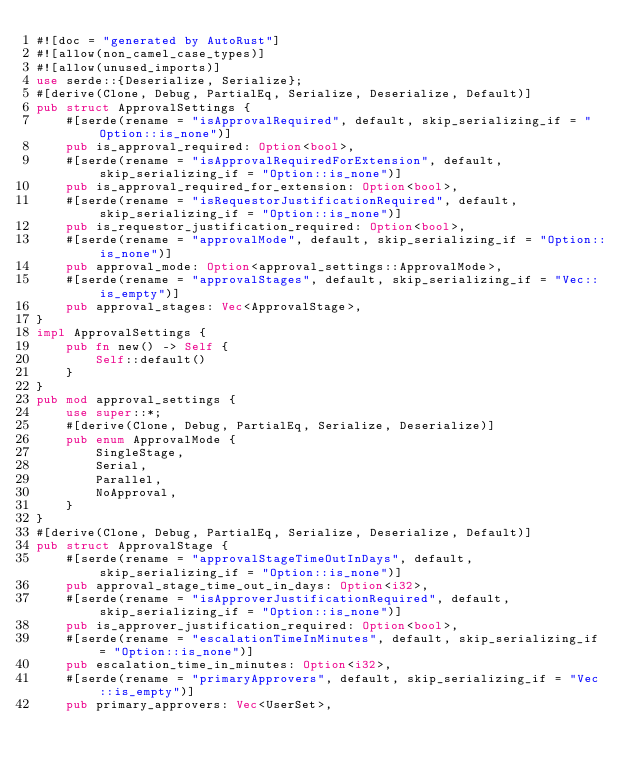<code> <loc_0><loc_0><loc_500><loc_500><_Rust_>#![doc = "generated by AutoRust"]
#![allow(non_camel_case_types)]
#![allow(unused_imports)]
use serde::{Deserialize, Serialize};
#[derive(Clone, Debug, PartialEq, Serialize, Deserialize, Default)]
pub struct ApprovalSettings {
    #[serde(rename = "isApprovalRequired", default, skip_serializing_if = "Option::is_none")]
    pub is_approval_required: Option<bool>,
    #[serde(rename = "isApprovalRequiredForExtension", default, skip_serializing_if = "Option::is_none")]
    pub is_approval_required_for_extension: Option<bool>,
    #[serde(rename = "isRequestorJustificationRequired", default, skip_serializing_if = "Option::is_none")]
    pub is_requestor_justification_required: Option<bool>,
    #[serde(rename = "approvalMode", default, skip_serializing_if = "Option::is_none")]
    pub approval_mode: Option<approval_settings::ApprovalMode>,
    #[serde(rename = "approvalStages", default, skip_serializing_if = "Vec::is_empty")]
    pub approval_stages: Vec<ApprovalStage>,
}
impl ApprovalSettings {
    pub fn new() -> Self {
        Self::default()
    }
}
pub mod approval_settings {
    use super::*;
    #[derive(Clone, Debug, PartialEq, Serialize, Deserialize)]
    pub enum ApprovalMode {
        SingleStage,
        Serial,
        Parallel,
        NoApproval,
    }
}
#[derive(Clone, Debug, PartialEq, Serialize, Deserialize, Default)]
pub struct ApprovalStage {
    #[serde(rename = "approvalStageTimeOutInDays", default, skip_serializing_if = "Option::is_none")]
    pub approval_stage_time_out_in_days: Option<i32>,
    #[serde(rename = "isApproverJustificationRequired", default, skip_serializing_if = "Option::is_none")]
    pub is_approver_justification_required: Option<bool>,
    #[serde(rename = "escalationTimeInMinutes", default, skip_serializing_if = "Option::is_none")]
    pub escalation_time_in_minutes: Option<i32>,
    #[serde(rename = "primaryApprovers", default, skip_serializing_if = "Vec::is_empty")]
    pub primary_approvers: Vec<UserSet>,</code> 